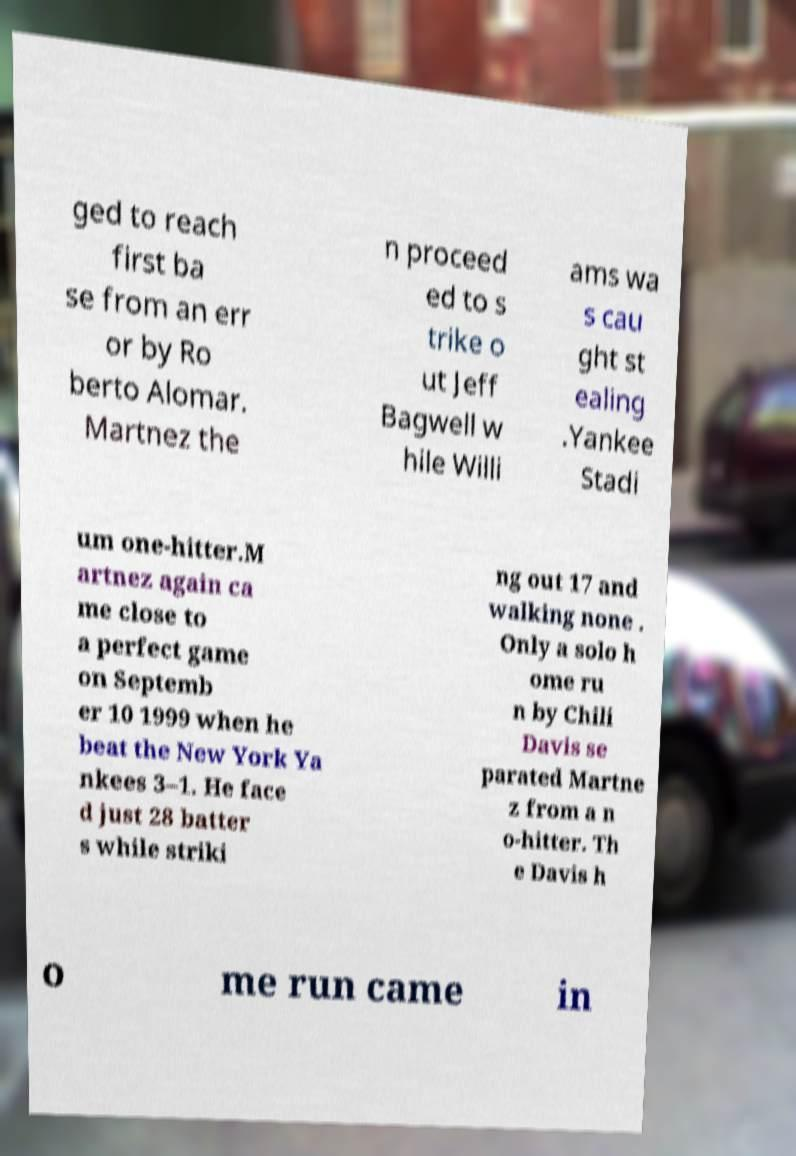Please identify and transcribe the text found in this image. ged to reach first ba se from an err or by Ro berto Alomar. Martnez the n proceed ed to s trike o ut Jeff Bagwell w hile Willi ams wa s cau ght st ealing .Yankee Stadi um one-hitter.M artnez again ca me close to a perfect game on Septemb er 10 1999 when he beat the New York Ya nkees 3–1. He face d just 28 batter s while striki ng out 17 and walking none . Only a solo h ome ru n by Chili Davis se parated Martne z from a n o-hitter. Th e Davis h o me run came in 